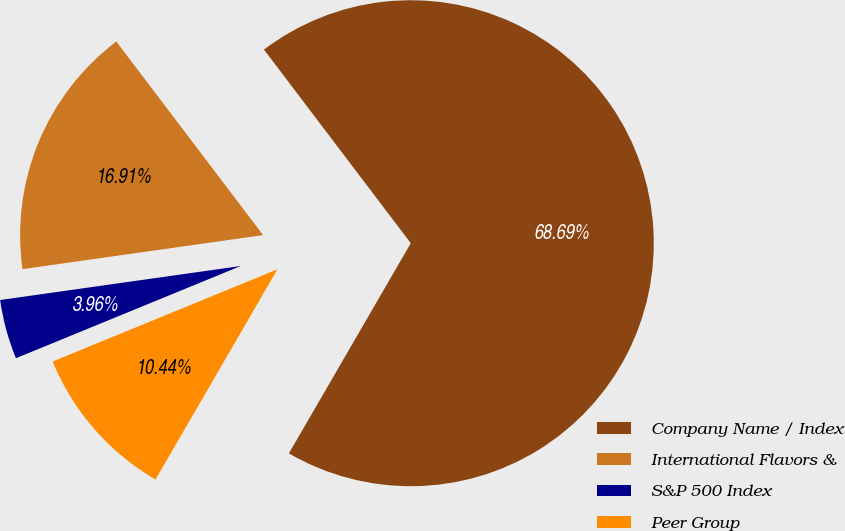Convert chart. <chart><loc_0><loc_0><loc_500><loc_500><pie_chart><fcel>Company Name / Index<fcel>International Flavors &<fcel>S&P 500 Index<fcel>Peer Group<nl><fcel>68.69%<fcel>16.91%<fcel>3.96%<fcel>10.44%<nl></chart> 